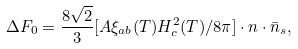<formula> <loc_0><loc_0><loc_500><loc_500>\Delta F _ { 0 } = \frac { 8 \sqrt { 2 } } { 3 } [ A \xi _ { a b } ( T ) H ^ { 2 } _ { c } ( T ) / 8 \pi ] \cdot n \cdot \bar { n } _ { s } ,</formula> 